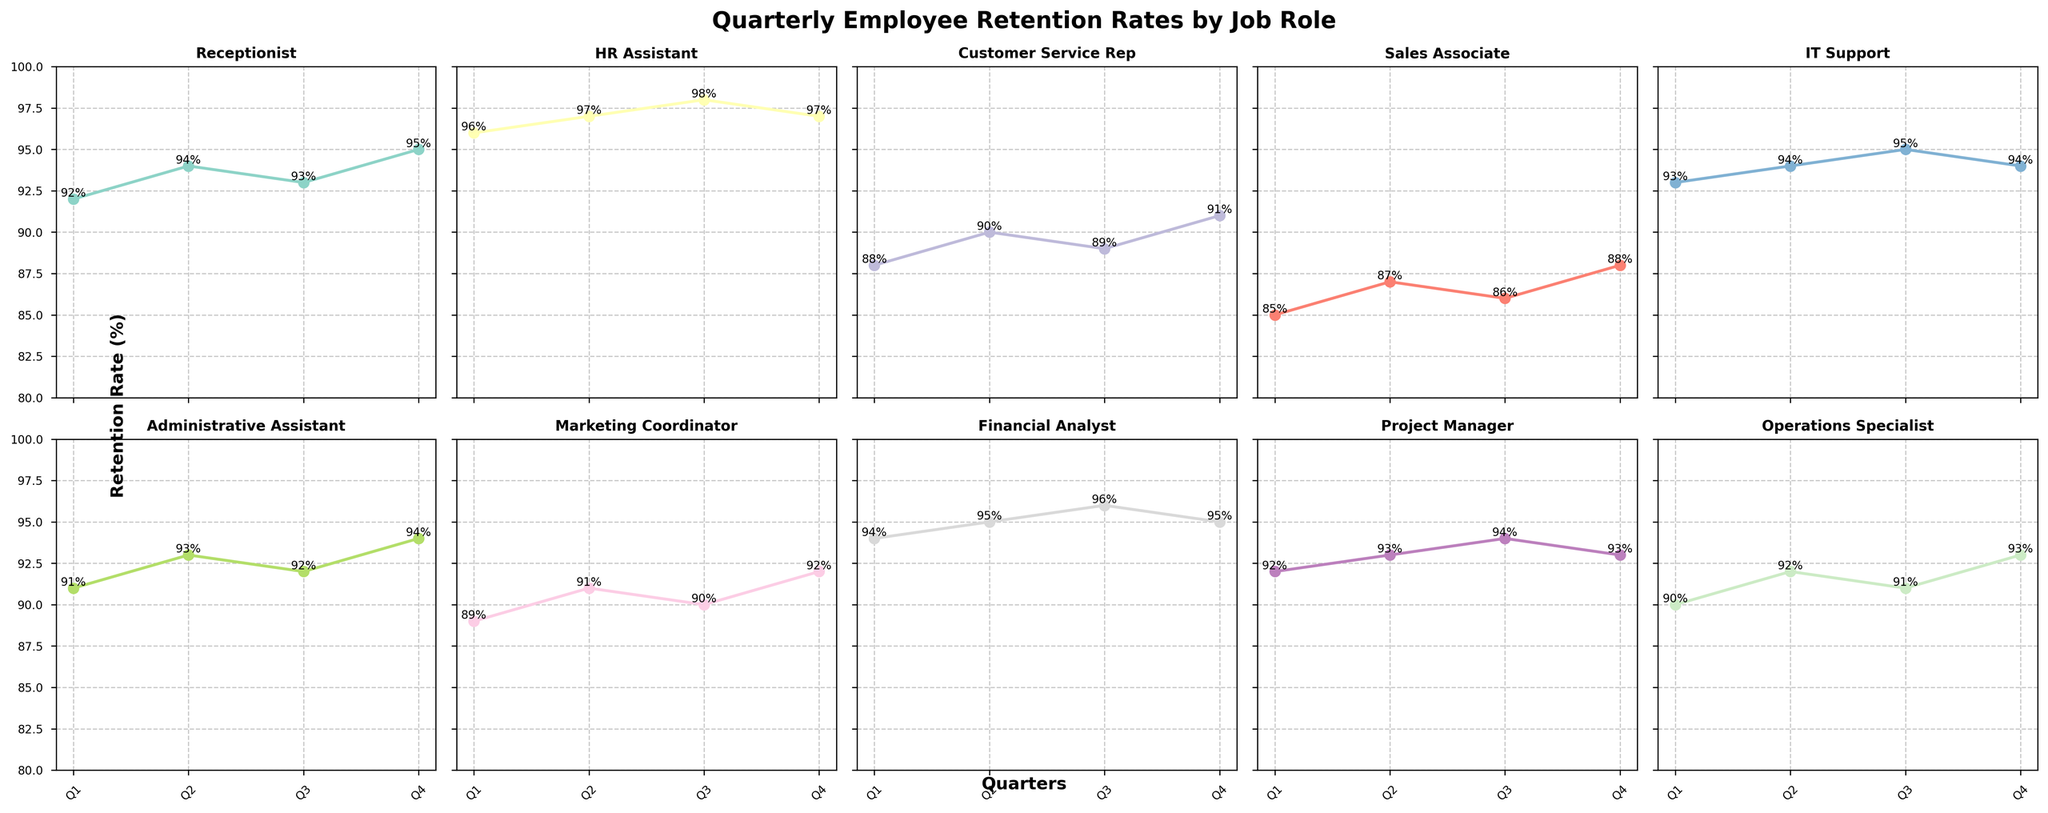What is the average quarterly retention rate for Marketing Coordinators? To find the average retention rate, sum the quarterly retention rates and divide by the number of quarters. For Marketing Coordinators, the rates are 89, 91, 90, and 92. Adding these (89 + 91 + 90 + 92) equals 362. Dividing 362 by 4 results in an average rate of 90.5.
Answer: 90.5% Which job role has the highest retention rate in Q4? To determine this, review Q4 retention rates across all job roles. The rates are: Receptionist (95%), HR Assistant (97%), Customer Service Rep (91%), Sales Associate (88%), IT Support (94%), Administrative Assistant (94%), Marketing Coordinator (92%), Financial Analyst (95%), Project Manager (93%), Operations Specialist (93%). The HR Assistant has the highest rate at 97%.
Answer: HR Assistant Do Receptionists or Sales Associates have a higher average retention rate? Calculate the average retention rate for each role. For Receptionist: (92 + 94 + 93 + 95) / 4 = 93.5%. For Sales Associate: (85 + 87 + 86 + 88) / 4 = 86.5%. The Receptionist has the higher average rate at 93.5%.
Answer: Receptionist Which job role saw the greatest increase in retention rate between Q1 and Q4? To find this, calculate the difference between Q1 and Q4 for each job role. Receptionist: 95 - 92 = 3%, HR Assistant: 97 - 96 = 1%, Customer Service Rep: 91 - 88 = 3%, Sales Associate: 88 - 85 = 3%, IT Support: 94 - 93 = 1%, Administrative Assistant: 94 - 91 = 3%, Marketing Coordinator: 92 - 89 = 3%, Financial Analyst: 95 - 94 = 1%, Project Manager: 93 - 92 = 1%, Operations Specialist: 93 - 90 = 3%. Multiple roles (Receptionist, Customer Service Rep, Sales Associate, Administrative Assistant, Marketing Coordinator, Operations Specialist) saw an increase of 3%.
Answer: Receptionist, Customer Service Rep, Sales Associate, Administrative Assistant, Marketing Coordinator, Operations Specialist Compare the retention rates of the IT Support and Financial Analyst roles in Q3. Review the Q3 retention rates for each role. IT Support is 95%, and Financial Analyst is 96%. The Financial Analyst’s retention rate is 1% higher than the IT Support.
Answer: Financial Analyst What is the range of quarterly retention rates for Operations Specialists? The range is found by subtracting the smallest value from the largest. For Operations Specialists, the rates are 90, 92, 91, and 93. The largest value is 93%, and the smallest is 90%. This gives a range of 93% - 90% = 3%.
Answer: 3% Which job role has the most consistent retention rates across all quarters (least variation)? Check the retention rates for consistency (less variation). The HR Assistant's rates are 96%, 97%, 98%, and 97% which are very close together, indicating high consistency. Other roles show more variation in their rates.
Answer: HR Assistant What is the total retention rate for the Receptionist over all four quarters? Add the retention rates for each quarter: 92 + 94 + 93 + 95 = 374%.
Answer: 374% How does the Q2 retention rate for Customer Service Reps compare to the Q4 retention rate for Sales Associates? The Q2 retention rate for Customer Service Reps is 90%. The Q4 retention rate for Sales Associates is 88%. Therefore, the Customer Service Rep’s Q2 retention rate is 2% higher than the Sales Associate’s Q4 retention rate.
Answer: Customer Service Rep’s Q2 rate is higher Which quarter had the highest retention rates across most job roles? Check the retention rates per quarter for each job role to identify the quarter with the highest retention rates. Q4 frequently shows high retention rates for many roles (e.g., Receptionist 95%, HR Assistant 97%, Customer Service Rep 91%, etc.).
Answer: Q4 